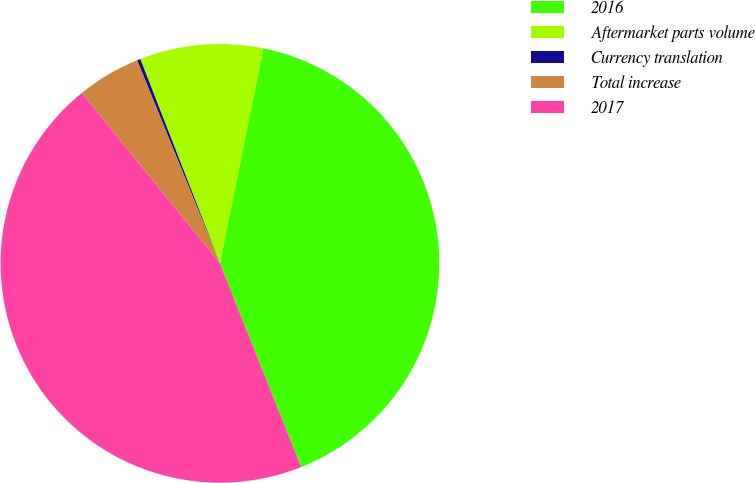Convert chart. <chart><loc_0><loc_0><loc_500><loc_500><pie_chart><fcel>2016<fcel>Aftermarket parts volume<fcel>Currency translation<fcel>Total increase<fcel>2017<nl><fcel>40.79%<fcel>9.09%<fcel>0.25%<fcel>4.67%<fcel>45.21%<nl></chart> 